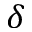Convert formula to latex. <formula><loc_0><loc_0><loc_500><loc_500>\delta</formula> 